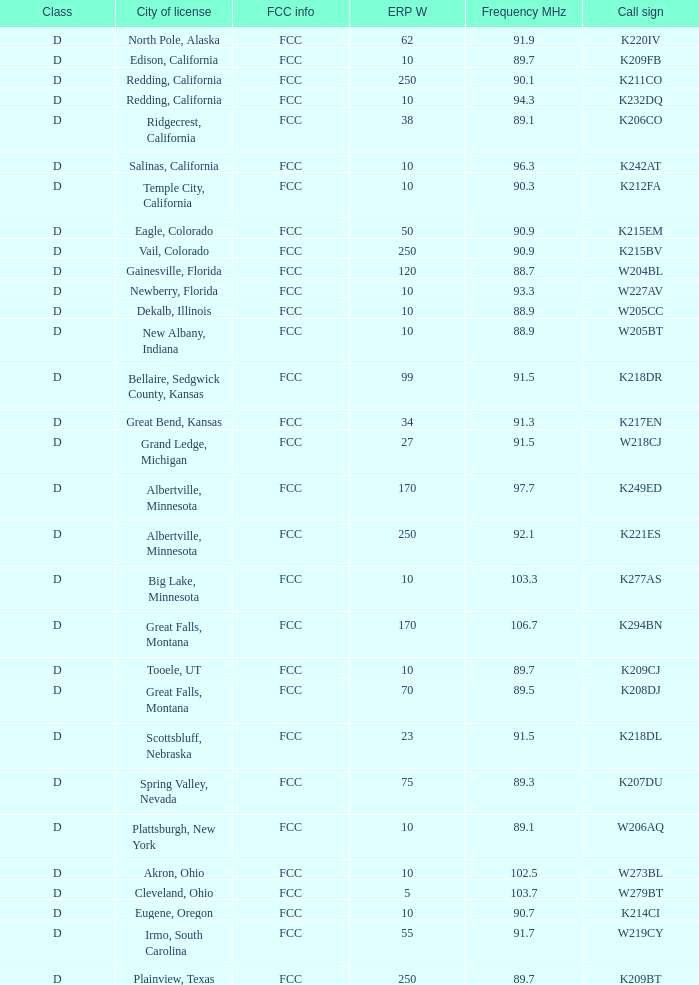What is the class of the translator with 10 ERP W and a call sign of w273bl? D. Parse the full table. {'header': ['Class', 'City of license', 'FCC info', 'ERP W', 'Frequency MHz', 'Call sign'], 'rows': [['D', 'North Pole, Alaska', 'FCC', '62', '91.9', 'K220IV'], ['D', 'Edison, California', 'FCC', '10', '89.7', 'K209FB'], ['D', 'Redding, California', 'FCC', '250', '90.1', 'K211CO'], ['D', 'Redding, California', 'FCC', '10', '94.3', 'K232DQ'], ['D', 'Ridgecrest, California', 'FCC', '38', '89.1', 'K206CO'], ['D', 'Salinas, California', 'FCC', '10', '96.3', 'K242AT'], ['D', 'Temple City, California', 'FCC', '10', '90.3', 'K212FA'], ['D', 'Eagle, Colorado', 'FCC', '50', '90.9', 'K215EM'], ['D', 'Vail, Colorado', 'FCC', '250', '90.9', 'K215BV'], ['D', 'Gainesville, Florida', 'FCC', '120', '88.7', 'W204BL'], ['D', 'Newberry, Florida', 'FCC', '10', '93.3', 'W227AV'], ['D', 'Dekalb, Illinois', 'FCC', '10', '88.9', 'W205CC'], ['D', 'New Albany, Indiana', 'FCC', '10', '88.9', 'W205BT'], ['D', 'Bellaire, Sedgwick County, Kansas', 'FCC', '99', '91.5', 'K218DR'], ['D', 'Great Bend, Kansas', 'FCC', '34', '91.3', 'K217EN'], ['D', 'Grand Ledge, Michigan', 'FCC', '27', '91.5', 'W218CJ'], ['D', 'Albertville, Minnesota', 'FCC', '170', '97.7', 'K249ED'], ['D', 'Albertville, Minnesota', 'FCC', '250', '92.1', 'K221ES'], ['D', 'Big Lake, Minnesota', 'FCC', '10', '103.3', 'K277AS'], ['D', 'Great Falls, Montana', 'FCC', '170', '106.7', 'K294BN'], ['D', 'Tooele, UT', 'FCC', '10', '89.7', 'K209CJ'], ['D', 'Great Falls, Montana', 'FCC', '70', '89.5', 'K208DJ'], ['D', 'Scottsbluff, Nebraska', 'FCC', '23', '91.5', 'K218DL'], ['D', 'Spring Valley, Nevada', 'FCC', '75', '89.3', 'K207DU'], ['D', 'Plattsburgh, New York', 'FCC', '10', '89.1', 'W206AQ'], ['D', 'Akron, Ohio', 'FCC', '10', '102.5', 'W273BL'], ['D', 'Cleveland, Ohio', 'FCC', '5', '103.7', 'W279BT'], ['D', 'Eugene, Oregon', 'FCC', '10', '90.7', 'K214CI'], ['D', 'Irmo, South Carolina', 'FCC', '55', '91.7', 'W219CY'], ['D', 'Plainview, Texas', 'FCC', '250', '89.7', 'K209BT']]} 